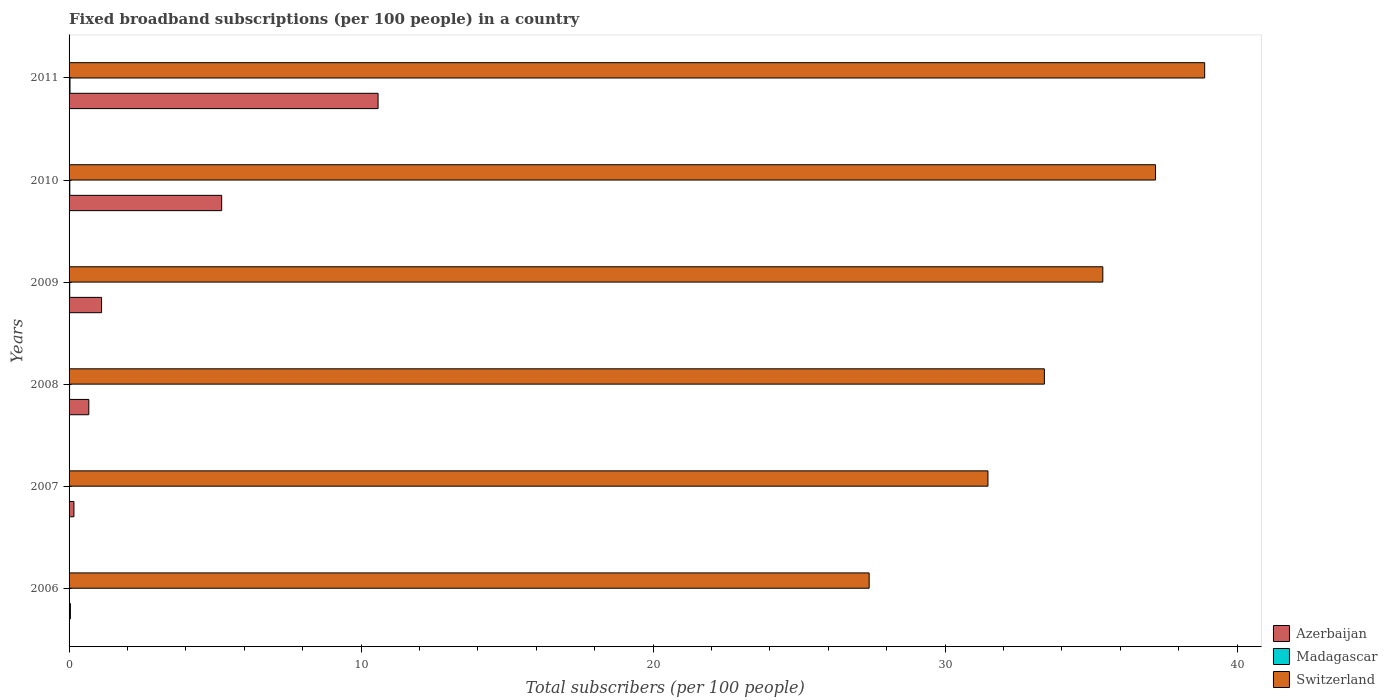How many groups of bars are there?
Keep it short and to the point. 6. Are the number of bars per tick equal to the number of legend labels?
Offer a very short reply. Yes. What is the number of broadband subscriptions in Madagascar in 2011?
Make the answer very short. 0.03. Across all years, what is the maximum number of broadband subscriptions in Switzerland?
Offer a terse response. 38.89. Across all years, what is the minimum number of broadband subscriptions in Madagascar?
Your response must be concise. 0.01. In which year was the number of broadband subscriptions in Madagascar maximum?
Your response must be concise. 2011. What is the total number of broadband subscriptions in Madagascar in the graph?
Make the answer very short. 0.12. What is the difference between the number of broadband subscriptions in Madagascar in 2010 and that in 2011?
Your answer should be very brief. -0.01. What is the difference between the number of broadband subscriptions in Madagascar in 2009 and the number of broadband subscriptions in Switzerland in 2011?
Provide a short and direct response. -38.87. What is the average number of broadband subscriptions in Madagascar per year?
Provide a short and direct response. 0.02. In the year 2007, what is the difference between the number of broadband subscriptions in Switzerland and number of broadband subscriptions in Madagascar?
Your answer should be very brief. 31.46. In how many years, is the number of broadband subscriptions in Madagascar greater than 34 ?
Your answer should be compact. 0. What is the ratio of the number of broadband subscriptions in Switzerland in 2009 to that in 2010?
Provide a succinct answer. 0.95. Is the number of broadband subscriptions in Azerbaijan in 2010 less than that in 2011?
Make the answer very short. Yes. Is the difference between the number of broadband subscriptions in Switzerland in 2007 and 2011 greater than the difference between the number of broadband subscriptions in Madagascar in 2007 and 2011?
Your answer should be very brief. No. What is the difference between the highest and the second highest number of broadband subscriptions in Azerbaijan?
Make the answer very short. 5.36. What is the difference between the highest and the lowest number of broadband subscriptions in Madagascar?
Ensure brevity in your answer.  0.02. Is the sum of the number of broadband subscriptions in Switzerland in 2009 and 2011 greater than the maximum number of broadband subscriptions in Madagascar across all years?
Ensure brevity in your answer.  Yes. What does the 3rd bar from the top in 2006 represents?
Provide a succinct answer. Azerbaijan. What does the 1st bar from the bottom in 2007 represents?
Ensure brevity in your answer.  Azerbaijan. Are all the bars in the graph horizontal?
Provide a short and direct response. Yes. How many years are there in the graph?
Make the answer very short. 6. Does the graph contain any zero values?
Offer a terse response. No. Does the graph contain grids?
Your response must be concise. No. Where does the legend appear in the graph?
Your answer should be very brief. Bottom right. What is the title of the graph?
Provide a succinct answer. Fixed broadband subscriptions (per 100 people) in a country. What is the label or title of the X-axis?
Offer a terse response. Total subscribers (per 100 people). What is the label or title of the Y-axis?
Offer a very short reply. Years. What is the Total subscribers (per 100 people) of Azerbaijan in 2006?
Offer a very short reply. 0.05. What is the Total subscribers (per 100 people) in Madagascar in 2006?
Provide a succinct answer. 0.01. What is the Total subscribers (per 100 people) in Switzerland in 2006?
Ensure brevity in your answer.  27.4. What is the Total subscribers (per 100 people) in Azerbaijan in 2007?
Provide a succinct answer. 0.17. What is the Total subscribers (per 100 people) of Madagascar in 2007?
Ensure brevity in your answer.  0.01. What is the Total subscribers (per 100 people) of Switzerland in 2007?
Provide a succinct answer. 31.47. What is the Total subscribers (per 100 people) in Azerbaijan in 2008?
Provide a succinct answer. 0.68. What is the Total subscribers (per 100 people) of Madagascar in 2008?
Your response must be concise. 0.02. What is the Total subscribers (per 100 people) in Switzerland in 2008?
Keep it short and to the point. 33.4. What is the Total subscribers (per 100 people) of Azerbaijan in 2009?
Ensure brevity in your answer.  1.11. What is the Total subscribers (per 100 people) of Madagascar in 2009?
Offer a terse response. 0.02. What is the Total subscribers (per 100 people) in Switzerland in 2009?
Provide a succinct answer. 35.4. What is the Total subscribers (per 100 people) in Azerbaijan in 2010?
Keep it short and to the point. 5.23. What is the Total subscribers (per 100 people) of Madagascar in 2010?
Provide a succinct answer. 0.03. What is the Total subscribers (per 100 people) in Switzerland in 2010?
Give a very brief answer. 37.21. What is the Total subscribers (per 100 people) of Azerbaijan in 2011?
Your answer should be very brief. 10.58. What is the Total subscribers (per 100 people) in Madagascar in 2011?
Make the answer very short. 0.03. What is the Total subscribers (per 100 people) in Switzerland in 2011?
Provide a short and direct response. 38.89. Across all years, what is the maximum Total subscribers (per 100 people) in Azerbaijan?
Give a very brief answer. 10.58. Across all years, what is the maximum Total subscribers (per 100 people) of Madagascar?
Your response must be concise. 0.03. Across all years, what is the maximum Total subscribers (per 100 people) in Switzerland?
Provide a short and direct response. 38.89. Across all years, what is the minimum Total subscribers (per 100 people) in Azerbaijan?
Give a very brief answer. 0.05. Across all years, what is the minimum Total subscribers (per 100 people) in Madagascar?
Offer a terse response. 0.01. Across all years, what is the minimum Total subscribers (per 100 people) of Switzerland?
Give a very brief answer. 27.4. What is the total Total subscribers (per 100 people) of Azerbaijan in the graph?
Keep it short and to the point. 17.81. What is the total Total subscribers (per 100 people) of Madagascar in the graph?
Make the answer very short. 0.12. What is the total Total subscribers (per 100 people) in Switzerland in the graph?
Your response must be concise. 203.77. What is the difference between the Total subscribers (per 100 people) in Azerbaijan in 2006 and that in 2007?
Offer a very short reply. -0.12. What is the difference between the Total subscribers (per 100 people) of Madagascar in 2006 and that in 2007?
Provide a succinct answer. -0. What is the difference between the Total subscribers (per 100 people) of Switzerland in 2006 and that in 2007?
Keep it short and to the point. -4.07. What is the difference between the Total subscribers (per 100 people) in Azerbaijan in 2006 and that in 2008?
Make the answer very short. -0.63. What is the difference between the Total subscribers (per 100 people) in Madagascar in 2006 and that in 2008?
Provide a short and direct response. -0.01. What is the difference between the Total subscribers (per 100 people) in Switzerland in 2006 and that in 2008?
Offer a very short reply. -6. What is the difference between the Total subscribers (per 100 people) of Azerbaijan in 2006 and that in 2009?
Keep it short and to the point. -1.07. What is the difference between the Total subscribers (per 100 people) of Madagascar in 2006 and that in 2009?
Your answer should be very brief. -0.02. What is the difference between the Total subscribers (per 100 people) in Switzerland in 2006 and that in 2009?
Keep it short and to the point. -8. What is the difference between the Total subscribers (per 100 people) of Azerbaijan in 2006 and that in 2010?
Your response must be concise. -5.18. What is the difference between the Total subscribers (per 100 people) in Madagascar in 2006 and that in 2010?
Give a very brief answer. -0.02. What is the difference between the Total subscribers (per 100 people) in Switzerland in 2006 and that in 2010?
Your response must be concise. -9.81. What is the difference between the Total subscribers (per 100 people) of Azerbaijan in 2006 and that in 2011?
Offer a terse response. -10.54. What is the difference between the Total subscribers (per 100 people) of Madagascar in 2006 and that in 2011?
Provide a short and direct response. -0.02. What is the difference between the Total subscribers (per 100 people) in Switzerland in 2006 and that in 2011?
Make the answer very short. -11.49. What is the difference between the Total subscribers (per 100 people) in Azerbaijan in 2007 and that in 2008?
Your answer should be very brief. -0.51. What is the difference between the Total subscribers (per 100 people) in Madagascar in 2007 and that in 2008?
Provide a succinct answer. -0.01. What is the difference between the Total subscribers (per 100 people) in Switzerland in 2007 and that in 2008?
Keep it short and to the point. -1.93. What is the difference between the Total subscribers (per 100 people) of Azerbaijan in 2007 and that in 2009?
Offer a very short reply. -0.95. What is the difference between the Total subscribers (per 100 people) of Madagascar in 2007 and that in 2009?
Ensure brevity in your answer.  -0.01. What is the difference between the Total subscribers (per 100 people) of Switzerland in 2007 and that in 2009?
Your response must be concise. -3.93. What is the difference between the Total subscribers (per 100 people) in Azerbaijan in 2007 and that in 2010?
Your answer should be compact. -5.06. What is the difference between the Total subscribers (per 100 people) of Madagascar in 2007 and that in 2010?
Your response must be concise. -0.01. What is the difference between the Total subscribers (per 100 people) in Switzerland in 2007 and that in 2010?
Keep it short and to the point. -5.74. What is the difference between the Total subscribers (per 100 people) in Azerbaijan in 2007 and that in 2011?
Ensure brevity in your answer.  -10.42. What is the difference between the Total subscribers (per 100 people) in Madagascar in 2007 and that in 2011?
Provide a short and direct response. -0.02. What is the difference between the Total subscribers (per 100 people) in Switzerland in 2007 and that in 2011?
Your answer should be compact. -7.42. What is the difference between the Total subscribers (per 100 people) of Azerbaijan in 2008 and that in 2009?
Ensure brevity in your answer.  -0.44. What is the difference between the Total subscribers (per 100 people) in Madagascar in 2008 and that in 2009?
Provide a short and direct response. -0. What is the difference between the Total subscribers (per 100 people) of Switzerland in 2008 and that in 2009?
Provide a succinct answer. -2. What is the difference between the Total subscribers (per 100 people) of Azerbaijan in 2008 and that in 2010?
Your answer should be compact. -4.55. What is the difference between the Total subscribers (per 100 people) in Madagascar in 2008 and that in 2010?
Your answer should be very brief. -0.01. What is the difference between the Total subscribers (per 100 people) in Switzerland in 2008 and that in 2010?
Provide a short and direct response. -3.8. What is the difference between the Total subscribers (per 100 people) of Azerbaijan in 2008 and that in 2011?
Your answer should be compact. -9.91. What is the difference between the Total subscribers (per 100 people) of Madagascar in 2008 and that in 2011?
Your answer should be compact. -0.01. What is the difference between the Total subscribers (per 100 people) of Switzerland in 2008 and that in 2011?
Ensure brevity in your answer.  -5.49. What is the difference between the Total subscribers (per 100 people) of Azerbaijan in 2009 and that in 2010?
Give a very brief answer. -4.11. What is the difference between the Total subscribers (per 100 people) of Madagascar in 2009 and that in 2010?
Provide a short and direct response. -0. What is the difference between the Total subscribers (per 100 people) of Switzerland in 2009 and that in 2010?
Keep it short and to the point. -1.8. What is the difference between the Total subscribers (per 100 people) in Azerbaijan in 2009 and that in 2011?
Offer a terse response. -9.47. What is the difference between the Total subscribers (per 100 people) of Madagascar in 2009 and that in 2011?
Give a very brief answer. -0.01. What is the difference between the Total subscribers (per 100 people) of Switzerland in 2009 and that in 2011?
Your answer should be compact. -3.49. What is the difference between the Total subscribers (per 100 people) in Azerbaijan in 2010 and that in 2011?
Your response must be concise. -5.36. What is the difference between the Total subscribers (per 100 people) of Madagascar in 2010 and that in 2011?
Provide a short and direct response. -0.01. What is the difference between the Total subscribers (per 100 people) in Switzerland in 2010 and that in 2011?
Keep it short and to the point. -1.68. What is the difference between the Total subscribers (per 100 people) of Azerbaijan in 2006 and the Total subscribers (per 100 people) of Madagascar in 2007?
Keep it short and to the point. 0.03. What is the difference between the Total subscribers (per 100 people) in Azerbaijan in 2006 and the Total subscribers (per 100 people) in Switzerland in 2007?
Offer a very short reply. -31.42. What is the difference between the Total subscribers (per 100 people) of Madagascar in 2006 and the Total subscribers (per 100 people) of Switzerland in 2007?
Offer a very short reply. -31.46. What is the difference between the Total subscribers (per 100 people) of Azerbaijan in 2006 and the Total subscribers (per 100 people) of Madagascar in 2008?
Provide a succinct answer. 0.03. What is the difference between the Total subscribers (per 100 people) in Azerbaijan in 2006 and the Total subscribers (per 100 people) in Switzerland in 2008?
Your answer should be very brief. -33.36. What is the difference between the Total subscribers (per 100 people) of Madagascar in 2006 and the Total subscribers (per 100 people) of Switzerland in 2008?
Provide a short and direct response. -33.4. What is the difference between the Total subscribers (per 100 people) of Azerbaijan in 2006 and the Total subscribers (per 100 people) of Madagascar in 2009?
Ensure brevity in your answer.  0.02. What is the difference between the Total subscribers (per 100 people) in Azerbaijan in 2006 and the Total subscribers (per 100 people) in Switzerland in 2009?
Your answer should be compact. -35.36. What is the difference between the Total subscribers (per 100 people) in Madagascar in 2006 and the Total subscribers (per 100 people) in Switzerland in 2009?
Provide a short and direct response. -35.4. What is the difference between the Total subscribers (per 100 people) in Azerbaijan in 2006 and the Total subscribers (per 100 people) in Madagascar in 2010?
Make the answer very short. 0.02. What is the difference between the Total subscribers (per 100 people) in Azerbaijan in 2006 and the Total subscribers (per 100 people) in Switzerland in 2010?
Your answer should be compact. -37.16. What is the difference between the Total subscribers (per 100 people) in Madagascar in 2006 and the Total subscribers (per 100 people) in Switzerland in 2010?
Provide a succinct answer. -37.2. What is the difference between the Total subscribers (per 100 people) of Azerbaijan in 2006 and the Total subscribers (per 100 people) of Madagascar in 2011?
Provide a short and direct response. 0.01. What is the difference between the Total subscribers (per 100 people) of Azerbaijan in 2006 and the Total subscribers (per 100 people) of Switzerland in 2011?
Provide a succinct answer. -38.85. What is the difference between the Total subscribers (per 100 people) in Madagascar in 2006 and the Total subscribers (per 100 people) in Switzerland in 2011?
Your response must be concise. -38.88. What is the difference between the Total subscribers (per 100 people) of Azerbaijan in 2007 and the Total subscribers (per 100 people) of Madagascar in 2008?
Your answer should be very brief. 0.15. What is the difference between the Total subscribers (per 100 people) in Azerbaijan in 2007 and the Total subscribers (per 100 people) in Switzerland in 2008?
Offer a very short reply. -33.24. What is the difference between the Total subscribers (per 100 people) of Madagascar in 2007 and the Total subscribers (per 100 people) of Switzerland in 2008?
Your answer should be very brief. -33.39. What is the difference between the Total subscribers (per 100 people) of Azerbaijan in 2007 and the Total subscribers (per 100 people) of Madagascar in 2009?
Your response must be concise. 0.14. What is the difference between the Total subscribers (per 100 people) of Azerbaijan in 2007 and the Total subscribers (per 100 people) of Switzerland in 2009?
Your answer should be compact. -35.24. What is the difference between the Total subscribers (per 100 people) in Madagascar in 2007 and the Total subscribers (per 100 people) in Switzerland in 2009?
Give a very brief answer. -35.39. What is the difference between the Total subscribers (per 100 people) in Azerbaijan in 2007 and the Total subscribers (per 100 people) in Madagascar in 2010?
Offer a terse response. 0.14. What is the difference between the Total subscribers (per 100 people) in Azerbaijan in 2007 and the Total subscribers (per 100 people) in Switzerland in 2010?
Provide a succinct answer. -37.04. What is the difference between the Total subscribers (per 100 people) of Madagascar in 2007 and the Total subscribers (per 100 people) of Switzerland in 2010?
Offer a terse response. -37.2. What is the difference between the Total subscribers (per 100 people) of Azerbaijan in 2007 and the Total subscribers (per 100 people) of Madagascar in 2011?
Your response must be concise. 0.13. What is the difference between the Total subscribers (per 100 people) in Azerbaijan in 2007 and the Total subscribers (per 100 people) in Switzerland in 2011?
Your answer should be compact. -38.73. What is the difference between the Total subscribers (per 100 people) of Madagascar in 2007 and the Total subscribers (per 100 people) of Switzerland in 2011?
Keep it short and to the point. -38.88. What is the difference between the Total subscribers (per 100 people) of Azerbaijan in 2008 and the Total subscribers (per 100 people) of Madagascar in 2009?
Your answer should be compact. 0.65. What is the difference between the Total subscribers (per 100 people) of Azerbaijan in 2008 and the Total subscribers (per 100 people) of Switzerland in 2009?
Give a very brief answer. -34.73. What is the difference between the Total subscribers (per 100 people) of Madagascar in 2008 and the Total subscribers (per 100 people) of Switzerland in 2009?
Your response must be concise. -35.39. What is the difference between the Total subscribers (per 100 people) of Azerbaijan in 2008 and the Total subscribers (per 100 people) of Madagascar in 2010?
Provide a short and direct response. 0.65. What is the difference between the Total subscribers (per 100 people) of Azerbaijan in 2008 and the Total subscribers (per 100 people) of Switzerland in 2010?
Ensure brevity in your answer.  -36.53. What is the difference between the Total subscribers (per 100 people) in Madagascar in 2008 and the Total subscribers (per 100 people) in Switzerland in 2010?
Make the answer very short. -37.19. What is the difference between the Total subscribers (per 100 people) of Azerbaijan in 2008 and the Total subscribers (per 100 people) of Madagascar in 2011?
Give a very brief answer. 0.64. What is the difference between the Total subscribers (per 100 people) of Azerbaijan in 2008 and the Total subscribers (per 100 people) of Switzerland in 2011?
Keep it short and to the point. -38.22. What is the difference between the Total subscribers (per 100 people) of Madagascar in 2008 and the Total subscribers (per 100 people) of Switzerland in 2011?
Keep it short and to the point. -38.87. What is the difference between the Total subscribers (per 100 people) in Azerbaijan in 2009 and the Total subscribers (per 100 people) in Madagascar in 2010?
Provide a short and direct response. 1.09. What is the difference between the Total subscribers (per 100 people) in Azerbaijan in 2009 and the Total subscribers (per 100 people) in Switzerland in 2010?
Provide a succinct answer. -36.09. What is the difference between the Total subscribers (per 100 people) in Madagascar in 2009 and the Total subscribers (per 100 people) in Switzerland in 2010?
Offer a terse response. -37.18. What is the difference between the Total subscribers (per 100 people) of Azerbaijan in 2009 and the Total subscribers (per 100 people) of Madagascar in 2011?
Your response must be concise. 1.08. What is the difference between the Total subscribers (per 100 people) of Azerbaijan in 2009 and the Total subscribers (per 100 people) of Switzerland in 2011?
Give a very brief answer. -37.78. What is the difference between the Total subscribers (per 100 people) of Madagascar in 2009 and the Total subscribers (per 100 people) of Switzerland in 2011?
Keep it short and to the point. -38.87. What is the difference between the Total subscribers (per 100 people) in Azerbaijan in 2010 and the Total subscribers (per 100 people) in Madagascar in 2011?
Provide a short and direct response. 5.19. What is the difference between the Total subscribers (per 100 people) of Azerbaijan in 2010 and the Total subscribers (per 100 people) of Switzerland in 2011?
Your answer should be compact. -33.67. What is the difference between the Total subscribers (per 100 people) of Madagascar in 2010 and the Total subscribers (per 100 people) of Switzerland in 2011?
Make the answer very short. -38.87. What is the average Total subscribers (per 100 people) in Azerbaijan per year?
Keep it short and to the point. 2.97. What is the average Total subscribers (per 100 people) of Madagascar per year?
Provide a succinct answer. 0.02. What is the average Total subscribers (per 100 people) in Switzerland per year?
Make the answer very short. 33.96. In the year 2006, what is the difference between the Total subscribers (per 100 people) in Azerbaijan and Total subscribers (per 100 people) in Madagascar?
Provide a succinct answer. 0.04. In the year 2006, what is the difference between the Total subscribers (per 100 people) of Azerbaijan and Total subscribers (per 100 people) of Switzerland?
Your response must be concise. -27.36. In the year 2006, what is the difference between the Total subscribers (per 100 people) of Madagascar and Total subscribers (per 100 people) of Switzerland?
Your response must be concise. -27.39. In the year 2007, what is the difference between the Total subscribers (per 100 people) in Azerbaijan and Total subscribers (per 100 people) in Madagascar?
Offer a terse response. 0.15. In the year 2007, what is the difference between the Total subscribers (per 100 people) in Azerbaijan and Total subscribers (per 100 people) in Switzerland?
Provide a succinct answer. -31.3. In the year 2007, what is the difference between the Total subscribers (per 100 people) of Madagascar and Total subscribers (per 100 people) of Switzerland?
Make the answer very short. -31.46. In the year 2008, what is the difference between the Total subscribers (per 100 people) of Azerbaijan and Total subscribers (per 100 people) of Madagascar?
Provide a succinct answer. 0.66. In the year 2008, what is the difference between the Total subscribers (per 100 people) of Azerbaijan and Total subscribers (per 100 people) of Switzerland?
Keep it short and to the point. -32.73. In the year 2008, what is the difference between the Total subscribers (per 100 people) of Madagascar and Total subscribers (per 100 people) of Switzerland?
Give a very brief answer. -33.38. In the year 2009, what is the difference between the Total subscribers (per 100 people) in Azerbaijan and Total subscribers (per 100 people) in Madagascar?
Keep it short and to the point. 1.09. In the year 2009, what is the difference between the Total subscribers (per 100 people) of Azerbaijan and Total subscribers (per 100 people) of Switzerland?
Give a very brief answer. -34.29. In the year 2009, what is the difference between the Total subscribers (per 100 people) in Madagascar and Total subscribers (per 100 people) in Switzerland?
Provide a short and direct response. -35.38. In the year 2010, what is the difference between the Total subscribers (per 100 people) in Azerbaijan and Total subscribers (per 100 people) in Madagascar?
Your response must be concise. 5.2. In the year 2010, what is the difference between the Total subscribers (per 100 people) in Azerbaijan and Total subscribers (per 100 people) in Switzerland?
Give a very brief answer. -31.98. In the year 2010, what is the difference between the Total subscribers (per 100 people) of Madagascar and Total subscribers (per 100 people) of Switzerland?
Your answer should be compact. -37.18. In the year 2011, what is the difference between the Total subscribers (per 100 people) in Azerbaijan and Total subscribers (per 100 people) in Madagascar?
Provide a short and direct response. 10.55. In the year 2011, what is the difference between the Total subscribers (per 100 people) of Azerbaijan and Total subscribers (per 100 people) of Switzerland?
Keep it short and to the point. -28.31. In the year 2011, what is the difference between the Total subscribers (per 100 people) of Madagascar and Total subscribers (per 100 people) of Switzerland?
Offer a terse response. -38.86. What is the ratio of the Total subscribers (per 100 people) of Azerbaijan in 2006 to that in 2007?
Provide a succinct answer. 0.27. What is the ratio of the Total subscribers (per 100 people) in Madagascar in 2006 to that in 2007?
Your response must be concise. 0.59. What is the ratio of the Total subscribers (per 100 people) of Switzerland in 2006 to that in 2007?
Ensure brevity in your answer.  0.87. What is the ratio of the Total subscribers (per 100 people) in Azerbaijan in 2006 to that in 2008?
Your response must be concise. 0.07. What is the ratio of the Total subscribers (per 100 people) in Madagascar in 2006 to that in 2008?
Give a very brief answer. 0.41. What is the ratio of the Total subscribers (per 100 people) of Switzerland in 2006 to that in 2008?
Make the answer very short. 0.82. What is the ratio of the Total subscribers (per 100 people) in Azerbaijan in 2006 to that in 2009?
Make the answer very short. 0.04. What is the ratio of the Total subscribers (per 100 people) of Madagascar in 2006 to that in 2009?
Your answer should be very brief. 0.32. What is the ratio of the Total subscribers (per 100 people) in Switzerland in 2006 to that in 2009?
Offer a terse response. 0.77. What is the ratio of the Total subscribers (per 100 people) of Azerbaijan in 2006 to that in 2010?
Offer a very short reply. 0.01. What is the ratio of the Total subscribers (per 100 people) in Madagascar in 2006 to that in 2010?
Ensure brevity in your answer.  0.28. What is the ratio of the Total subscribers (per 100 people) of Switzerland in 2006 to that in 2010?
Keep it short and to the point. 0.74. What is the ratio of the Total subscribers (per 100 people) in Azerbaijan in 2006 to that in 2011?
Make the answer very short. 0. What is the ratio of the Total subscribers (per 100 people) of Madagascar in 2006 to that in 2011?
Give a very brief answer. 0.23. What is the ratio of the Total subscribers (per 100 people) of Switzerland in 2006 to that in 2011?
Provide a short and direct response. 0.7. What is the ratio of the Total subscribers (per 100 people) of Azerbaijan in 2007 to that in 2008?
Ensure brevity in your answer.  0.25. What is the ratio of the Total subscribers (per 100 people) of Madagascar in 2007 to that in 2008?
Your response must be concise. 0.69. What is the ratio of the Total subscribers (per 100 people) in Switzerland in 2007 to that in 2008?
Keep it short and to the point. 0.94. What is the ratio of the Total subscribers (per 100 people) of Azerbaijan in 2007 to that in 2009?
Your response must be concise. 0.15. What is the ratio of the Total subscribers (per 100 people) in Madagascar in 2007 to that in 2009?
Ensure brevity in your answer.  0.54. What is the ratio of the Total subscribers (per 100 people) of Azerbaijan in 2007 to that in 2010?
Provide a short and direct response. 0.03. What is the ratio of the Total subscribers (per 100 people) of Madagascar in 2007 to that in 2010?
Your answer should be very brief. 0.48. What is the ratio of the Total subscribers (per 100 people) in Switzerland in 2007 to that in 2010?
Offer a very short reply. 0.85. What is the ratio of the Total subscribers (per 100 people) of Azerbaijan in 2007 to that in 2011?
Provide a succinct answer. 0.02. What is the ratio of the Total subscribers (per 100 people) of Madagascar in 2007 to that in 2011?
Ensure brevity in your answer.  0.38. What is the ratio of the Total subscribers (per 100 people) of Switzerland in 2007 to that in 2011?
Ensure brevity in your answer.  0.81. What is the ratio of the Total subscribers (per 100 people) in Azerbaijan in 2008 to that in 2009?
Provide a short and direct response. 0.61. What is the ratio of the Total subscribers (per 100 people) of Madagascar in 2008 to that in 2009?
Your response must be concise. 0.78. What is the ratio of the Total subscribers (per 100 people) of Switzerland in 2008 to that in 2009?
Ensure brevity in your answer.  0.94. What is the ratio of the Total subscribers (per 100 people) in Azerbaijan in 2008 to that in 2010?
Your response must be concise. 0.13. What is the ratio of the Total subscribers (per 100 people) of Madagascar in 2008 to that in 2010?
Offer a very short reply. 0.68. What is the ratio of the Total subscribers (per 100 people) in Switzerland in 2008 to that in 2010?
Make the answer very short. 0.9. What is the ratio of the Total subscribers (per 100 people) of Azerbaijan in 2008 to that in 2011?
Keep it short and to the point. 0.06. What is the ratio of the Total subscribers (per 100 people) of Madagascar in 2008 to that in 2011?
Provide a succinct answer. 0.55. What is the ratio of the Total subscribers (per 100 people) of Switzerland in 2008 to that in 2011?
Give a very brief answer. 0.86. What is the ratio of the Total subscribers (per 100 people) in Azerbaijan in 2009 to that in 2010?
Give a very brief answer. 0.21. What is the ratio of the Total subscribers (per 100 people) of Madagascar in 2009 to that in 2010?
Offer a very short reply. 0.87. What is the ratio of the Total subscribers (per 100 people) of Switzerland in 2009 to that in 2010?
Your response must be concise. 0.95. What is the ratio of the Total subscribers (per 100 people) in Azerbaijan in 2009 to that in 2011?
Your answer should be compact. 0.11. What is the ratio of the Total subscribers (per 100 people) in Madagascar in 2009 to that in 2011?
Keep it short and to the point. 0.71. What is the ratio of the Total subscribers (per 100 people) of Switzerland in 2009 to that in 2011?
Ensure brevity in your answer.  0.91. What is the ratio of the Total subscribers (per 100 people) of Azerbaijan in 2010 to that in 2011?
Your response must be concise. 0.49. What is the ratio of the Total subscribers (per 100 people) in Madagascar in 2010 to that in 2011?
Make the answer very short. 0.81. What is the ratio of the Total subscribers (per 100 people) in Switzerland in 2010 to that in 2011?
Give a very brief answer. 0.96. What is the difference between the highest and the second highest Total subscribers (per 100 people) in Azerbaijan?
Provide a short and direct response. 5.36. What is the difference between the highest and the second highest Total subscribers (per 100 people) in Madagascar?
Provide a succinct answer. 0.01. What is the difference between the highest and the second highest Total subscribers (per 100 people) in Switzerland?
Keep it short and to the point. 1.68. What is the difference between the highest and the lowest Total subscribers (per 100 people) of Azerbaijan?
Your answer should be very brief. 10.54. What is the difference between the highest and the lowest Total subscribers (per 100 people) in Madagascar?
Your response must be concise. 0.02. What is the difference between the highest and the lowest Total subscribers (per 100 people) in Switzerland?
Offer a terse response. 11.49. 